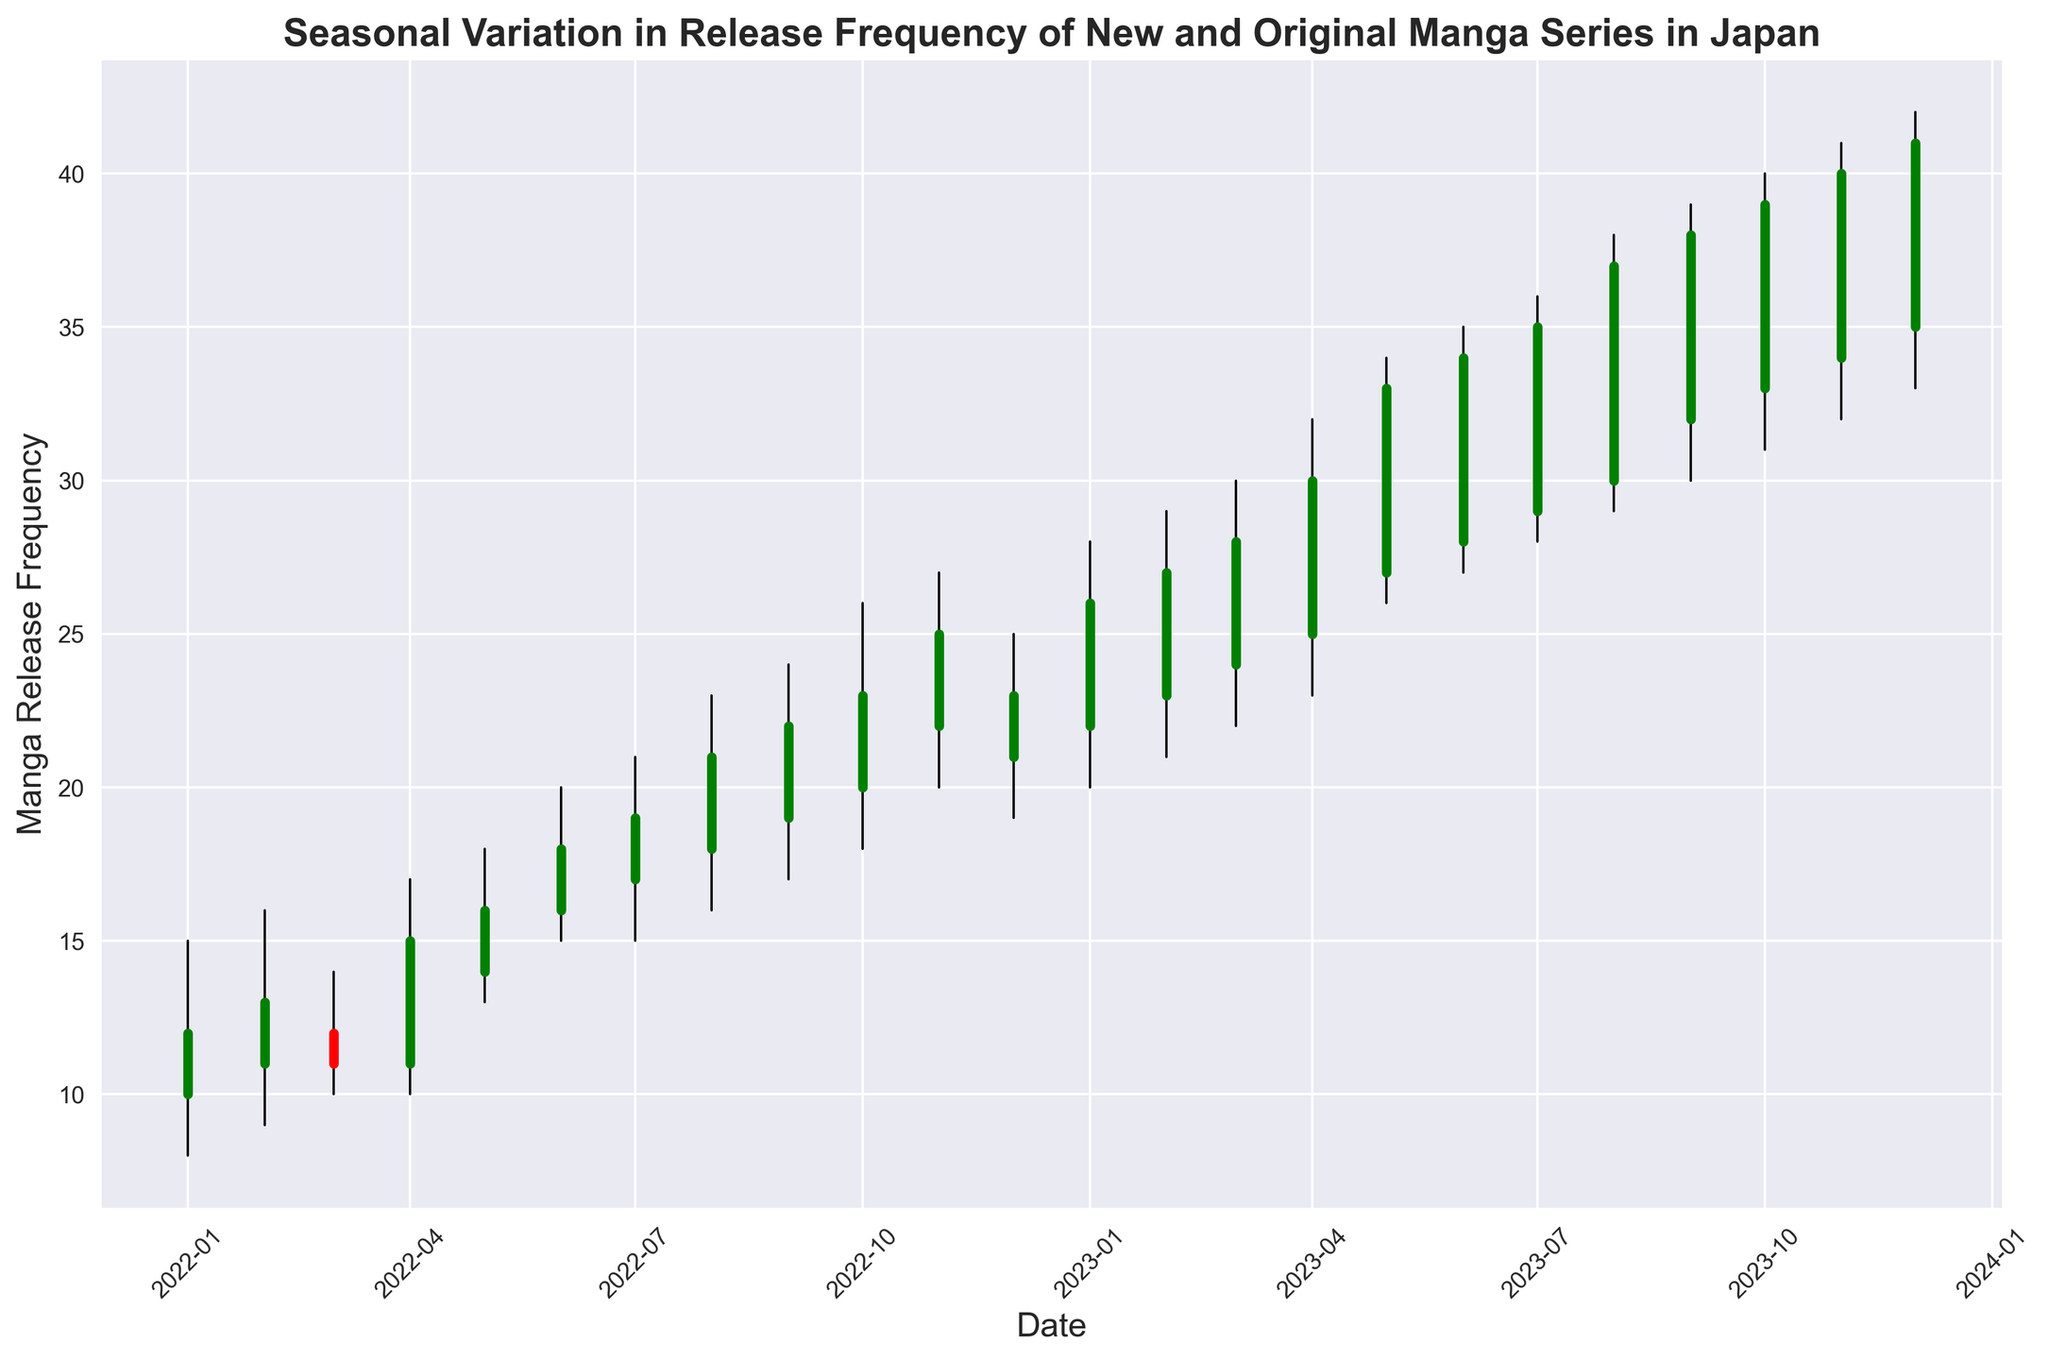What is the highest value seen on the chart, and in which month does it occur? To find the highest value, we should look at the top of the bars representing the "High" value for each month. The highest of these values is 42, which is seen in December 2023.
Answer: 42 in December 2023 Which month shows the smallest difference between the high and low values, and what is the difference? We need to calculate the difference between the high and low values for each month and identify the smallest difference. The smallest difference is in March 2022, where the high is 14 and the low is 10, giving a difference of 14 - 10 = 4.
Answer: March 2022, 4 In which month was there the greatest increase in the closing value compared to the previous month? We look for the largest positive difference between the closing values of consecutive months. The greatest increase in the closing value occurs from January 2023 to February 2023, where the closing value increases from 26 to 27 (an increase of 27 - 26 = 1).
Answer: January to February 2023 Which month experienced a decrease in closing value despite an increase in the opening value compared to the previous month? We need to identify a month where the closing value is lower than the previous month, but the opening value is higher. March 2022 shows this pattern. The opening value in February 2022 is 11, increasing to 12 in March 2022, but the closing value decreases from 13 in February 2022 to 11 in March 2022.
Answer: March 2022 What is the average closing value for the year 2023? To find the average, sum all the closing values for each month in 2023 and divide by the number of months. Summing the closing values for 2023: (26 + 27 + 28 + 30 + 33 + 34 + 35 + 37 + 38 + 39 + 40 + 41) = 408. There are 12 months, so the average is 408 / 12 = 34.
Answer: 34 Which month has the widest range between the high and low values? The range is calculated as the high value minus the low value. We look for the month with the highest difference. December 2023 has the widest range with a high of 42 and a low of 33, giving a range of 42 - 33 = 9.
Answer: December 2023 How many months have a closing value higher than 30? We count the number of months where the closing value exceeds 30. From April 2023 onwards, every month has a closing value higher than 30, giving: (30, 33, 34, 35, 37, 38, 39, 40, 41), which is 9 months.
Answer: 9 Between July and October 2023, which month has the second highest closing value? We compare the closing values for July, August, September, and October 2023: July (35), August (37), September (38), October (39). The second highest is 38 in September 2023.
Answer: September 2023 